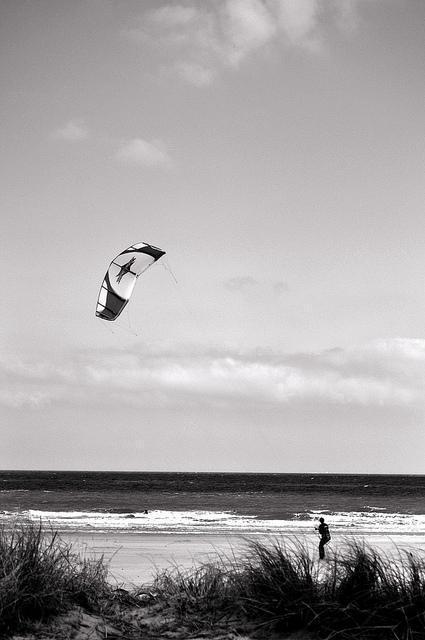How many of these bottles have yellow on the lid?
Give a very brief answer. 0. 